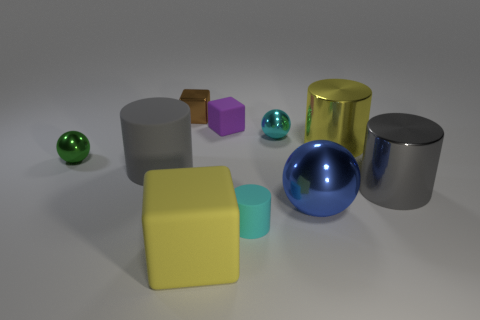There is a large yellow object right of the small cyan thing that is in front of the tiny metallic ball to the left of the brown object; what shape is it?
Offer a very short reply. Cylinder. There is a cyan sphere; what number of things are to the right of it?
Keep it short and to the point. 3. Do the cyan thing on the right side of the cyan matte cylinder and the large block have the same material?
Provide a short and direct response. No. What number of other objects are the same shape as the big gray metallic thing?
Your answer should be compact. 3. There is a block that is in front of the small cyan thing that is in front of the blue shiny sphere; what number of purple objects are behind it?
Offer a very short reply. 1. There is a shiny ball that is left of the large rubber cylinder; what color is it?
Ensure brevity in your answer.  Green. There is a tiny metal object to the right of the brown shiny object; is its color the same as the small matte cylinder?
Give a very brief answer. Yes. There is a purple matte thing that is the same shape as the tiny brown thing; what size is it?
Ensure brevity in your answer.  Small. There is a cyan object that is on the left side of the tiny cyan object behind the metallic cylinder on the left side of the gray metallic object; what is it made of?
Provide a succinct answer. Rubber. Is the number of rubber blocks that are in front of the yellow shiny cylinder greater than the number of small blocks that are in front of the large yellow matte cube?
Your response must be concise. Yes. 